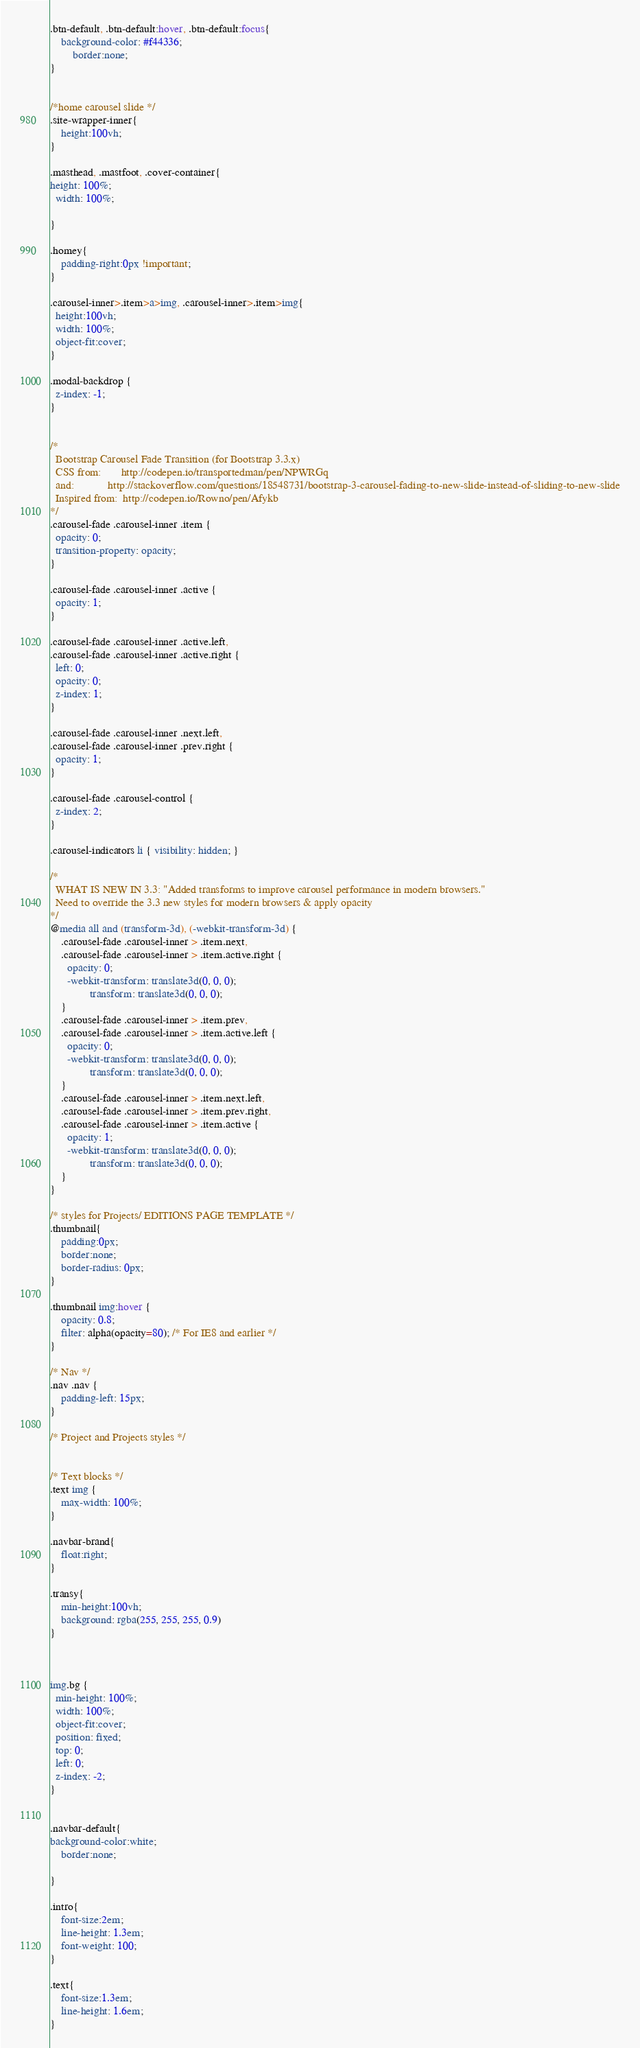<code> <loc_0><loc_0><loc_500><loc_500><_CSS_>
.btn-default, .btn-default:hover, .btn-default:focus{
    background-color: #f44336;
        border:none;
}


/*home carousel slide */
.site-wrapper-inner{
    height:100vh;
}

.masthead, .mastfoot, .cover-container{
height: 100%;
  width: 100%;

}

.homey{
    padding-right:0px !important;
}

.carousel-inner>.item>a>img, .carousel-inner>.item>img{
  height:100vh;
  width: 100%;
  object-fit:cover;
}

.modal-backdrop {
  z-index: -1;
}


/*
  Bootstrap Carousel Fade Transition (for Bootstrap 3.3.x)
  CSS from:       http://codepen.io/transportedman/pen/NPWRGq
  and:            http://stackoverflow.com/questions/18548731/bootstrap-3-carousel-fading-to-new-slide-instead-of-sliding-to-new-slide
  Inspired from:  http://codepen.io/Rowno/pen/Afykb 
*/
.carousel-fade .carousel-inner .item {
  opacity: 0;
  transition-property: opacity;
}

.carousel-fade .carousel-inner .active {
  opacity: 1;
}

.carousel-fade .carousel-inner .active.left,
.carousel-fade .carousel-inner .active.right {
  left: 0;
  opacity: 0;
  z-index: 1;
}

.carousel-fade .carousel-inner .next.left,
.carousel-fade .carousel-inner .prev.right {
  opacity: 1;
}

.carousel-fade .carousel-control {
  z-index: 2;
}

.carousel-indicators li { visibility: hidden; }

/*
  WHAT IS NEW IN 3.3: "Added transforms to improve carousel performance in modern browsers."
  Need to override the 3.3 new styles for modern browsers & apply opacity
*/
@media all and (transform-3d), (-webkit-transform-3d) {
    .carousel-fade .carousel-inner > .item.next,
    .carousel-fade .carousel-inner > .item.active.right {
      opacity: 0;
      -webkit-transform: translate3d(0, 0, 0);
              transform: translate3d(0, 0, 0);
    }
    .carousel-fade .carousel-inner > .item.prev,
    .carousel-fade .carousel-inner > .item.active.left {
      opacity: 0;
      -webkit-transform: translate3d(0, 0, 0);
              transform: translate3d(0, 0, 0);
    }
    .carousel-fade .carousel-inner > .item.next.left,
    .carousel-fade .carousel-inner > .item.prev.right,
    .carousel-fade .carousel-inner > .item.active {
      opacity: 1;
      -webkit-transform: translate3d(0, 0, 0);
              transform: translate3d(0, 0, 0);
    }
}

/* styles for Projects/ EDITIONS PAGE TEMPLATE */
.thumbnail{
    padding:0px;
    border:none;
    border-radius: 0px;
}

.thumbnail img:hover {
    opacity: 0.8;
    filter: alpha(opacity=80); /* For IE8 and earlier */
}

/* Nav */
.nav .nav {
	padding-left: 15px;
}

/* Project and Projects styles */


/* Text blocks */
.text img {
	max-width: 100%;
}

.navbar-brand{
    float:right;
}

.transy{
    min-height:100vh;
    background: rgba(255, 255, 255, 0.9)
}



img.bg {
  min-height: 100%;
  width: 100%;
  object-fit:cover;
  position: fixed;
  top: 0;
  left: 0;
  z-index: -2;
}


.navbar-default{
background-color:white;
    border:none;

}

.intro{
    font-size:2em;
    line-height: 1.3em;
    font-weight: 100;
}

.text{
    font-size:1.3em;
    line-height: 1.6em;
}












</code> 